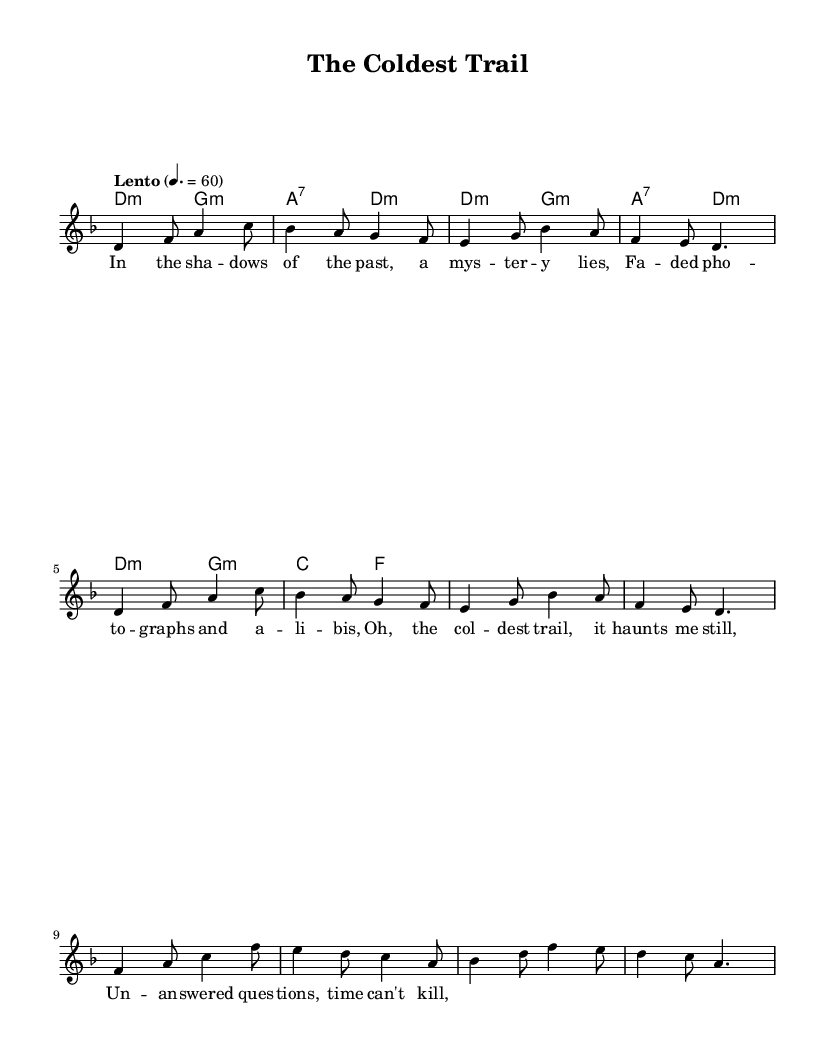What is the key signature of this music? The key signature is D minor, which has one flat (B flat). This is indicated at the beginning of the score before the staff, where key signatures are typically shown.
Answer: D minor What is the time signature of this music? The time signature is 6/8, which is indicated at the beginning of the score. It shows that there are six eighth notes in each measure, creating a compound rhythm typical of folk styles.
Answer: 6/8 What is the tempo marking of this piece? The tempo marking is "Lento," which means a slow tempo. It is indicated in the tempo marking section of the score, where it specifies how fast the piece should be played.
Answer: Lento How many measures are shown in the melody? The melody contains eight measures, which can be counted from the beginning of the melody section to the end, identifying the segment breaks marked by the bar lines.
Answer: Eight measures What instrument is primarily featured in this score? The primary instrument featured in this score is a voice, indicated by the label "lead" in the staff where the melody is written. Folk music often emphasizes lyrical storytelling through vocals.
Answer: Voice What theme is explored in the lyrics of this piece? The theme explored in the lyrics revolves around a mystery and unsolved questions, as suggested by phrases like "a mystery lies" and "unanswered questions." This reflects the typical storytelling element present in folk music, often dealing with darker human experiences.
Answer: Mystery What harmonies are predominantly used in this piece? The predominant harmonies used are D minor and G minor as shown in the chord section. The use of minor harmonies contributes to the dark and somber tone often found in folk ballads about unsolved mysteries.
Answer: D minor and G minor 